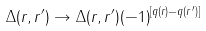Convert formula to latex. <formula><loc_0><loc_0><loc_500><loc_500>\Delta ( r , r ^ { \prime } ) \rightarrow \Delta ( r , r ^ { \prime } ) ( - 1 ) ^ { [ q ( r ) - q ( r ^ { \prime } ) ] }</formula> 